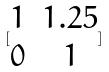Convert formula to latex. <formula><loc_0><loc_0><loc_500><loc_500>[ \begin{matrix} 1 & 1 . 2 5 \\ 0 & 1 \end{matrix} ]</formula> 